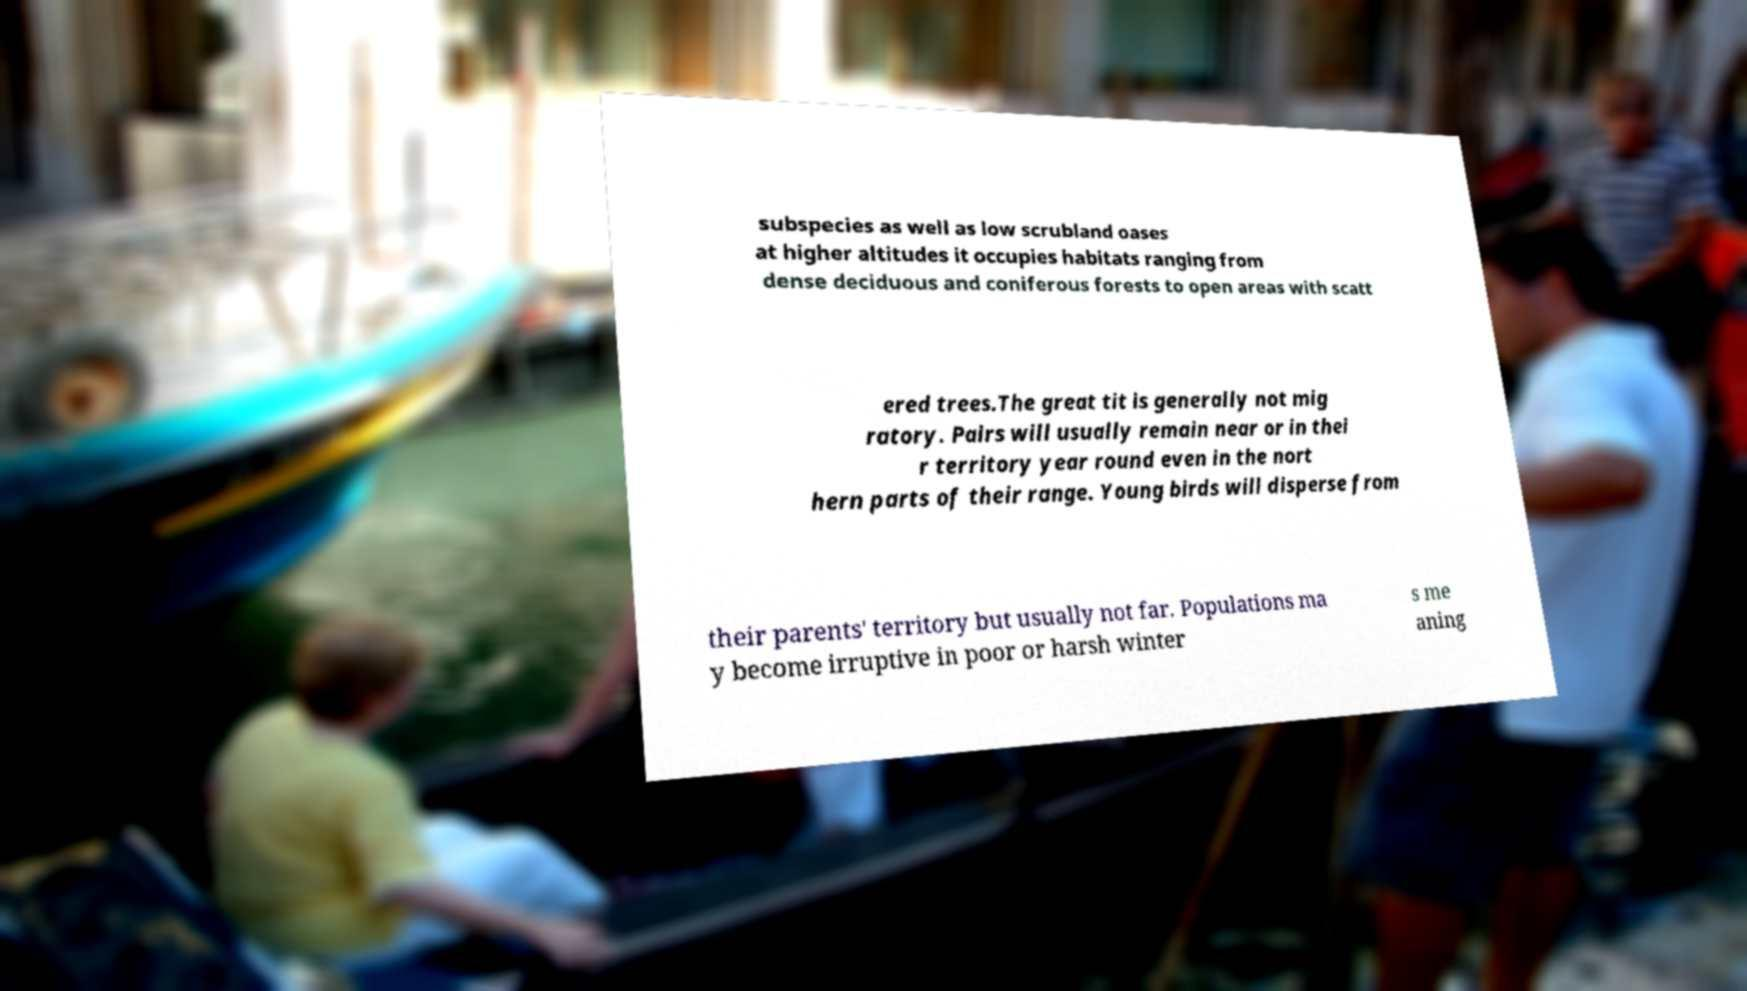Could you assist in decoding the text presented in this image and type it out clearly? subspecies as well as low scrubland oases at higher altitudes it occupies habitats ranging from dense deciduous and coniferous forests to open areas with scatt ered trees.The great tit is generally not mig ratory. Pairs will usually remain near or in thei r territory year round even in the nort hern parts of their range. Young birds will disperse from their parents' territory but usually not far. Populations ma y become irruptive in poor or harsh winter s me aning 